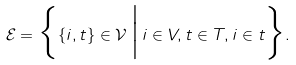<formula> <loc_0><loc_0><loc_500><loc_500>\mathcal { E } = \Big \{ \{ i , t \} \in \mathcal { V } \, \Big | \, i \in V , t \in T , i \in t \Big \} .</formula> 